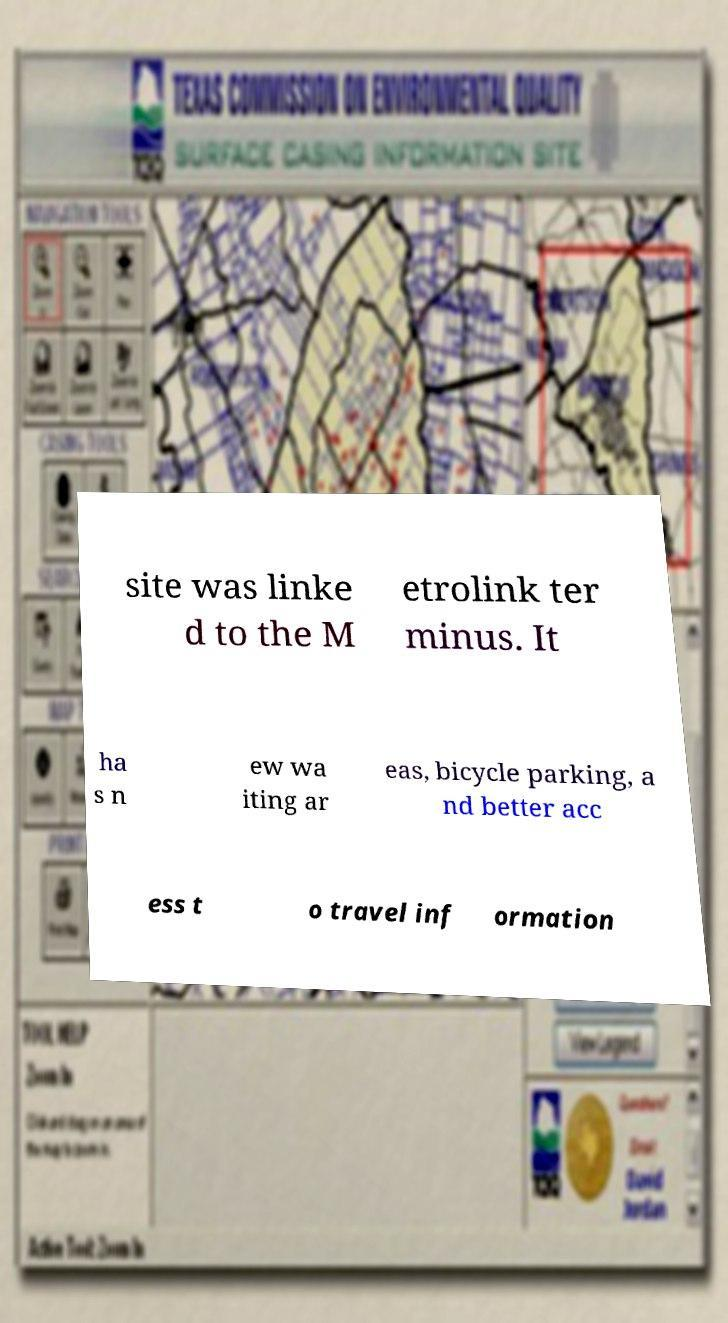Please identify and transcribe the text found in this image. site was linke d to the M etrolink ter minus. It ha s n ew wa iting ar eas, bicycle parking, a nd better acc ess t o travel inf ormation 